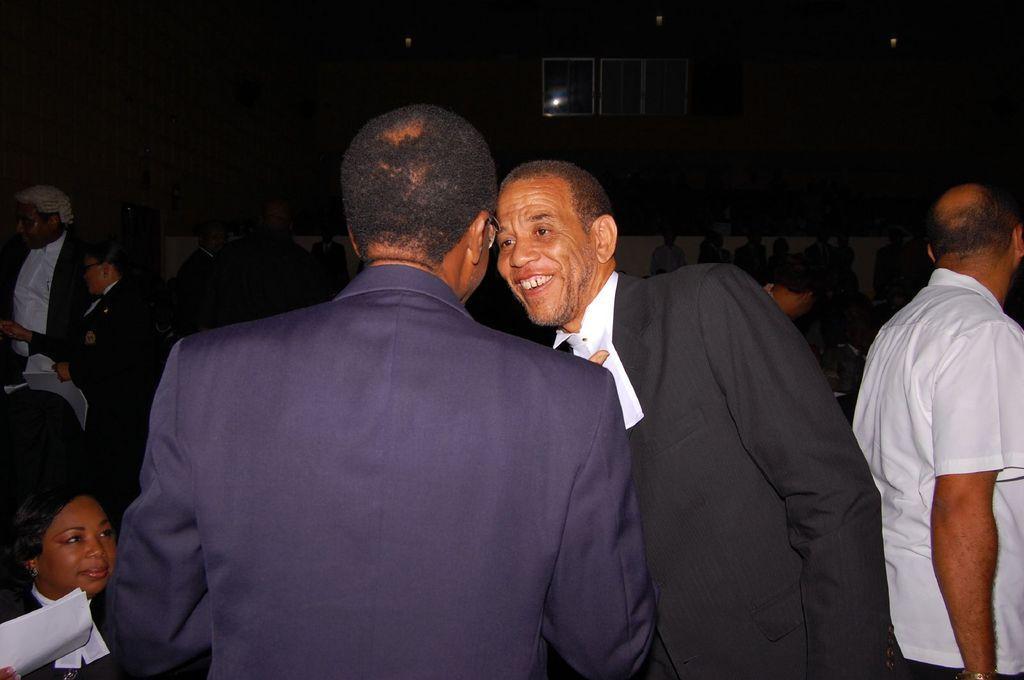How many persons are visible in the image? There are persons in the image, but the exact number cannot be determined from the provided facts. Can you describe the setting of the image? The image features persons in the foreground and background, with a wall, windows, and other objects in the background. What might be the purpose of the wall in the background? The purpose of the wall in the background cannot be determined from the provided facts. What other objects can be seen in the background of the image? There are windows and other objects in the background of the image, but their specific nature cannot be determined from the provided facts. What type of tree is growing in the background of the image? There is no tree present in the background of the image. Can you tell me the name of the aunt who is standing in the background of the image? There is no aunt mentioned in the image, and therefore no such person can be identified. 